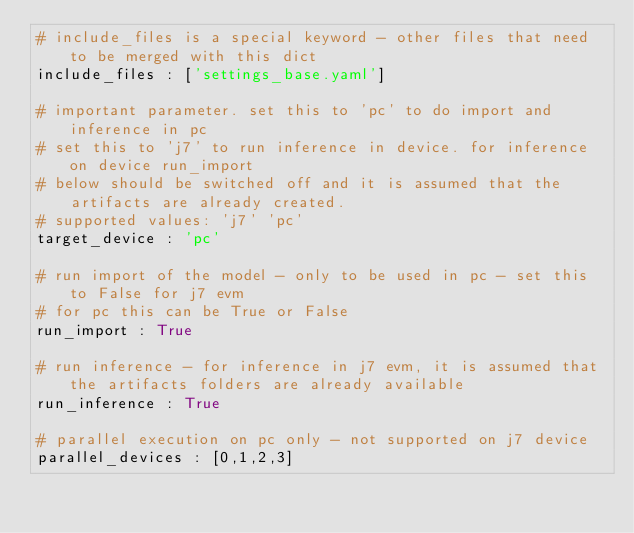Convert code to text. <code><loc_0><loc_0><loc_500><loc_500><_YAML_># include_files is a special keyword - other files that need to be merged with this dict
include_files : ['settings_base.yaml']

# important parameter. set this to 'pc' to do import and inference in pc
# set this to 'j7' to run inference in device. for inference on device run_import
# below should be switched off and it is assumed that the artifacts are already created.
# supported values: 'j7' 'pc'
target_device : 'pc'

# run import of the model - only to be used in pc - set this to False for j7 evm
# for pc this can be True or False
run_import : True

# run inference - for inference in j7 evm, it is assumed that the artifacts folders are already available
run_inference : True

# parallel execution on pc only - not supported on j7 device
parallel_devices : [0,1,2,3]
</code> 